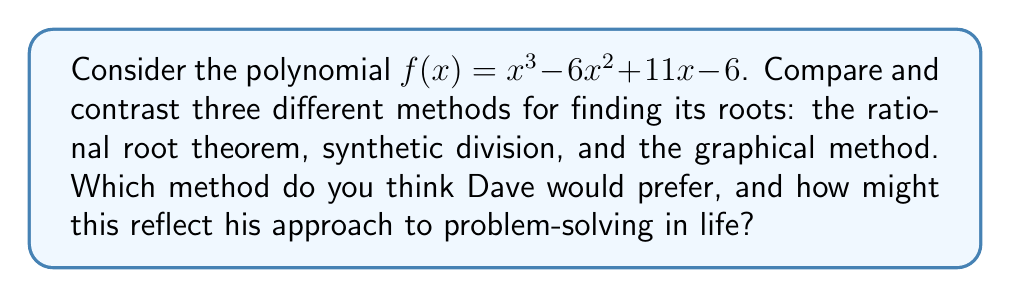Solve this math problem. Let's examine each method for finding the roots of $f(x) = x^3 - 6x^2 + 11x - 6$:

1. Rational Root Theorem:
This method suggests that if a polynomial equation has integer coefficients, then any rational solution, when reduced to lowest terms, will have a numerator that divides the constant term and a denominator that divides the leading coefficient.

Possible rational roots: $\pm 1, \pm 2, \pm 3, \pm 6$

Testing these values:
$f(1) = 1 - 6 + 11 - 6 = 0$
We find that 1 is a root.

2. Synthetic Division:
Using 1 as a root, we can use synthetic division to factor out $(x-1)$:

$$
\begin{array}{r|r r r r}
1 & 1 & -6 & 11 & -6 \\
& 1 & -5 & 6 \\
\hline
& 1 & -5 & 6 & 0
\end{array}
$$

This gives us: $f(x) = (x-1)(x^2 - 5x + 6)$

We can factor the quadratic further: $f(x) = (x-1)(x-2)(x-3)$

3. Graphical Method:
We can plot the function and look for x-intercepts:

[asy]
import graph;
size(200,200);
real f(real x) {return x^3 - 6x^2 + 11x - 6;}
draw(graph(f,-1,4),blue);
draw((-1,0)--(4,0),arrow=Arrow(TeXHead));
draw((0,-2)--(0,10),arrow=Arrow(TeXHead));
label("x",(4,0),E);
label("y",(0,10),N);
dot((1,0));
dot((2,0));
dot((3,0));
label("(1,0)",(1,0),SW);
label("(2,0)",(2,0),S);
label("(3,0)",(3,0),SE);
[/asy]

The graph crosses the x-axis at x = 1, 2, and 3, confirming our algebraic results.

Reflecting on Dave's approach:
The rational root theorem requires some initial guesswork but can quickly lead to a solution. Synthetic division is more methodical and step-by-step. The graphical method provides a visual representation but may lack precision.

Dave, being a philosophical and introspective person, might prefer the graphical method. It allows for a broader view of the problem, seeing how the function behaves overall, rather than just focusing on specific points. This could reflect an approach to life where Dave prefers to step back and see the bigger picture before diving into details.

However, Dave might also appreciate the logical progression of synthetic division, as it mirrors a thoughtful, step-by-step approach to problem-solving in life. The rational root theorem, while potentially quick, might seem too reliant on trial-and-error for Dave's taste.

Ultimately, Dave might find value in using all three methods in conjunction, recognizing that different approaches can offer unique insights, much like how diverse perspectives can enrich our understanding of life's challenges.
Answer: The roots of $f(x) = x^3 - 6x^2 + 11x - 6$ are $x = 1, 2, \text{ and } 3$. Dave, given his philosophical and introspective nature, might prefer the graphical method for its holistic view, but would likely appreciate the insights gained from all three methods, reflecting a comprehensive approach to problem-solving in life. 